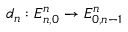Convert formula to latex. <formula><loc_0><loc_0><loc_500><loc_500>d _ { n } \colon E _ { n , 0 } ^ { n } \to E _ { 0 , n - 1 } ^ { n }</formula> 